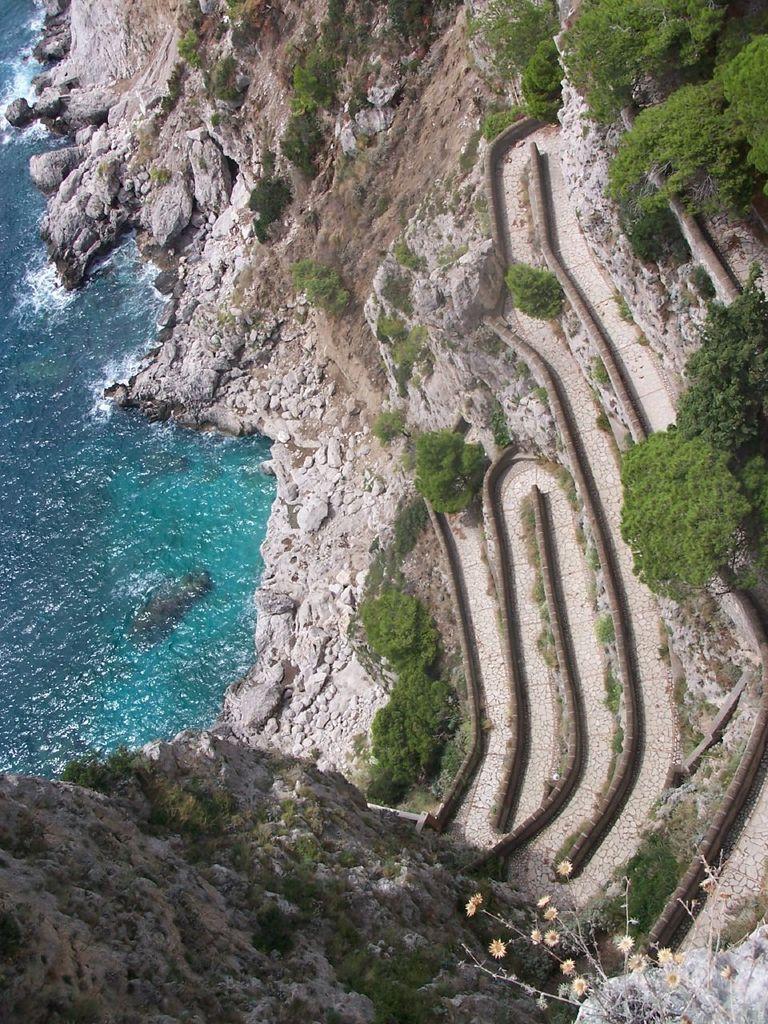Describe this image in one or two sentences. In this image I can see water, trees and mountains. This image is taken may be near the ocean. 